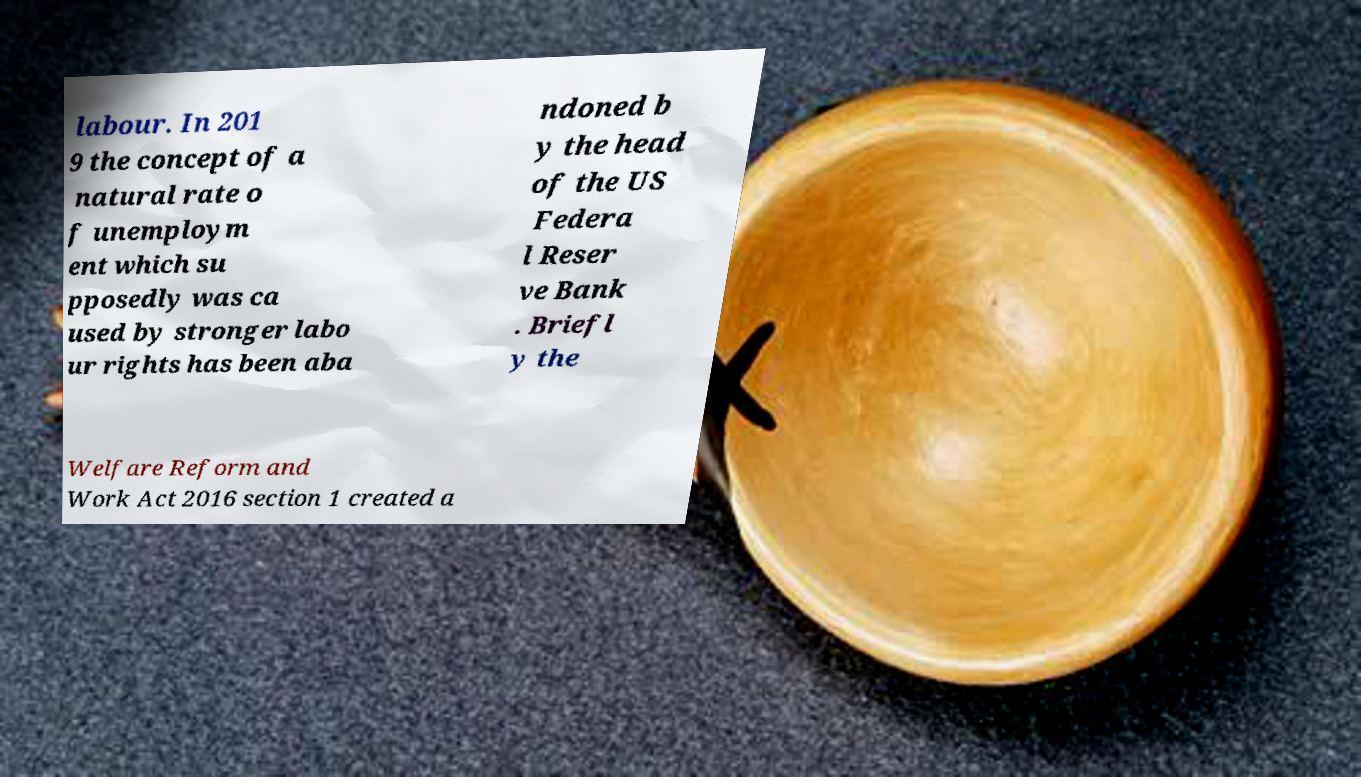Can you accurately transcribe the text from the provided image for me? labour. In 201 9 the concept of a natural rate o f unemploym ent which su pposedly was ca used by stronger labo ur rights has been aba ndoned b y the head of the US Federa l Reser ve Bank . Briefl y the Welfare Reform and Work Act 2016 section 1 created a 